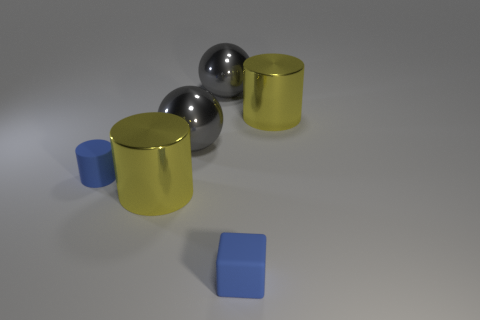There is a big gray metal sphere behind the yellow cylinder that is to the right of the blue rubber block; is there a gray sphere that is in front of it?
Give a very brief answer. Yes. What size is the thing that is both in front of the blue rubber cylinder and behind the tiny blue matte cube?
Give a very brief answer. Large. There is a yellow metal cylinder behind the large metal cylinder in front of the small blue matte thing behind the small cube; what is its size?
Provide a succinct answer. Large. There is a object that is left of the tiny block and in front of the tiny cylinder; what is its shape?
Your answer should be compact. Cylinder. There is a object that is the same color as the small matte block; what is it made of?
Give a very brief answer. Rubber. What number of cubes are small matte things or gray objects?
Your response must be concise. 1. There is a yellow metal thing that is on the left side of the matte cube; how big is it?
Ensure brevity in your answer.  Large. Is there a shiny ball that has the same color as the cube?
Provide a succinct answer. No. Is the size of the blue matte thing that is left of the rubber cube the same as the tiny blue cube?
Provide a succinct answer. Yes. What is the color of the small cube?
Your response must be concise. Blue. 